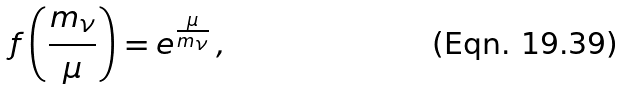Convert formula to latex. <formula><loc_0><loc_0><loc_500><loc_500>f \left ( \frac { m _ { \nu } } { \mu } \right ) = e ^ { \frac { \mu } { m _ { \nu } } } \, ,</formula> 